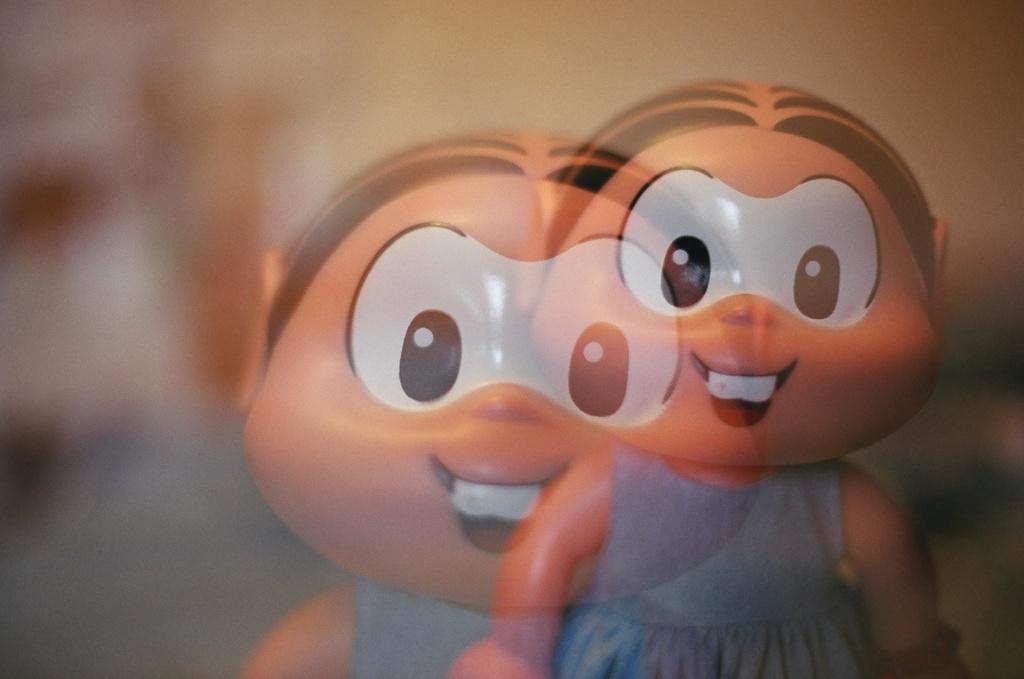Please provide a concise description of this image. In this image I can see the toy wearing the blue color dress and there is a blurred background. 